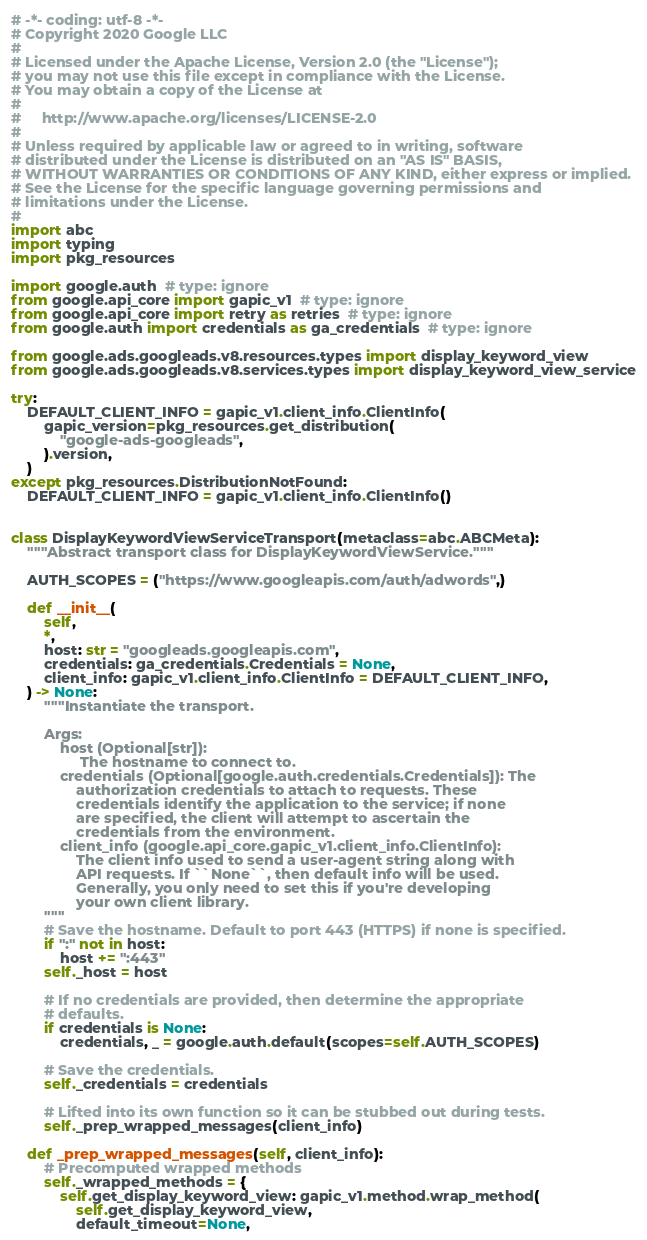<code> <loc_0><loc_0><loc_500><loc_500><_Python_># -*- coding: utf-8 -*-
# Copyright 2020 Google LLC
#
# Licensed under the Apache License, Version 2.0 (the "License");
# you may not use this file except in compliance with the License.
# You may obtain a copy of the License at
#
#     http://www.apache.org/licenses/LICENSE-2.0
#
# Unless required by applicable law or agreed to in writing, software
# distributed under the License is distributed on an "AS IS" BASIS,
# WITHOUT WARRANTIES OR CONDITIONS OF ANY KIND, either express or implied.
# See the License for the specific language governing permissions and
# limitations under the License.
#
import abc
import typing
import pkg_resources

import google.auth  # type: ignore
from google.api_core import gapic_v1  # type: ignore
from google.api_core import retry as retries  # type: ignore
from google.auth import credentials as ga_credentials  # type: ignore

from google.ads.googleads.v8.resources.types import display_keyword_view
from google.ads.googleads.v8.services.types import display_keyword_view_service

try:
    DEFAULT_CLIENT_INFO = gapic_v1.client_info.ClientInfo(
        gapic_version=pkg_resources.get_distribution(
            "google-ads-googleads",
        ).version,
    )
except pkg_resources.DistributionNotFound:
    DEFAULT_CLIENT_INFO = gapic_v1.client_info.ClientInfo()


class DisplayKeywordViewServiceTransport(metaclass=abc.ABCMeta):
    """Abstract transport class for DisplayKeywordViewService."""

    AUTH_SCOPES = ("https://www.googleapis.com/auth/adwords",)

    def __init__(
        self,
        *,
        host: str = "googleads.googleapis.com",
        credentials: ga_credentials.Credentials = None,
        client_info: gapic_v1.client_info.ClientInfo = DEFAULT_CLIENT_INFO,
    ) -> None:
        """Instantiate the transport.

        Args:
            host (Optional[str]):
                 The hostname to connect to.
            credentials (Optional[google.auth.credentials.Credentials]): The
                authorization credentials to attach to requests. These
                credentials identify the application to the service; if none
                are specified, the client will attempt to ascertain the
                credentials from the environment.
            client_info (google.api_core.gapic_v1.client_info.ClientInfo):
                The client info used to send a user-agent string along with
                API requests. If ``None``, then default info will be used.
                Generally, you only need to set this if you're developing
                your own client library.
        """
        # Save the hostname. Default to port 443 (HTTPS) if none is specified.
        if ":" not in host:
            host += ":443"
        self._host = host

        # If no credentials are provided, then determine the appropriate
        # defaults.
        if credentials is None:
            credentials, _ = google.auth.default(scopes=self.AUTH_SCOPES)

        # Save the credentials.
        self._credentials = credentials

        # Lifted into its own function so it can be stubbed out during tests.
        self._prep_wrapped_messages(client_info)

    def _prep_wrapped_messages(self, client_info):
        # Precomputed wrapped methods
        self._wrapped_methods = {
            self.get_display_keyword_view: gapic_v1.method.wrap_method(
                self.get_display_keyword_view,
                default_timeout=None,</code> 